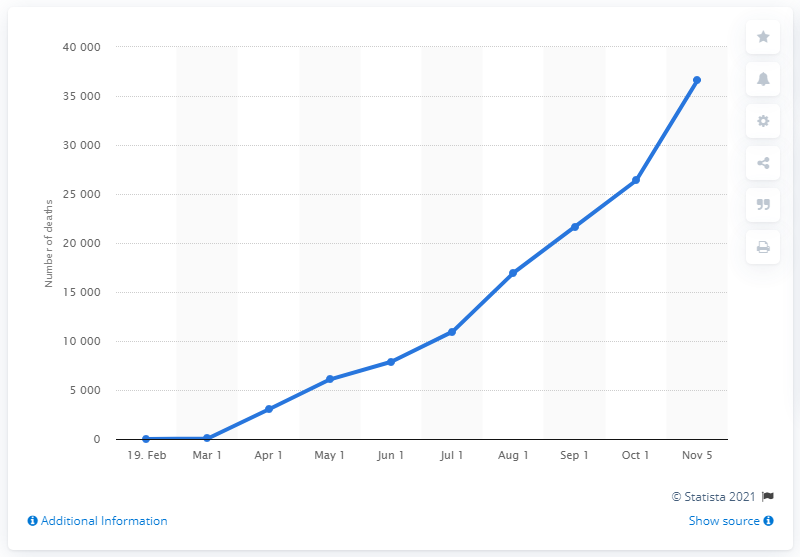Give some essential details in this illustration. As of November 5, 2020, a total of 36,585 deaths had been reported due to the COVID-19 pandemic in Iran. 